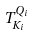<formula> <loc_0><loc_0><loc_500><loc_500>T _ { K _ { i } } ^ { Q _ { i } }</formula> 